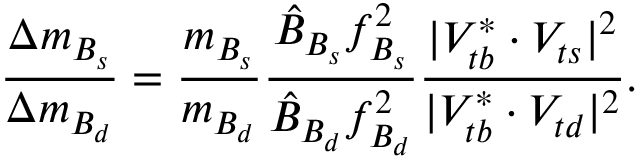<formula> <loc_0><loc_0><loc_500><loc_500>\frac { \Delta m _ { B _ { s } } } { \Delta m _ { B _ { d } } } = \frac { m _ { B _ { s } } } { m _ { B _ { d } } } \frac { \hat { B } _ { B _ { s } } f _ { B _ { s } } ^ { 2 } } { \hat { B } _ { B _ { d } } f _ { B _ { d } } ^ { 2 } } \frac { | V _ { t b } ^ { \ast } \cdot V _ { t s } | ^ { 2 } } { | V _ { t b } ^ { \ast } \cdot V _ { t d } | ^ { 2 } } .</formula> 